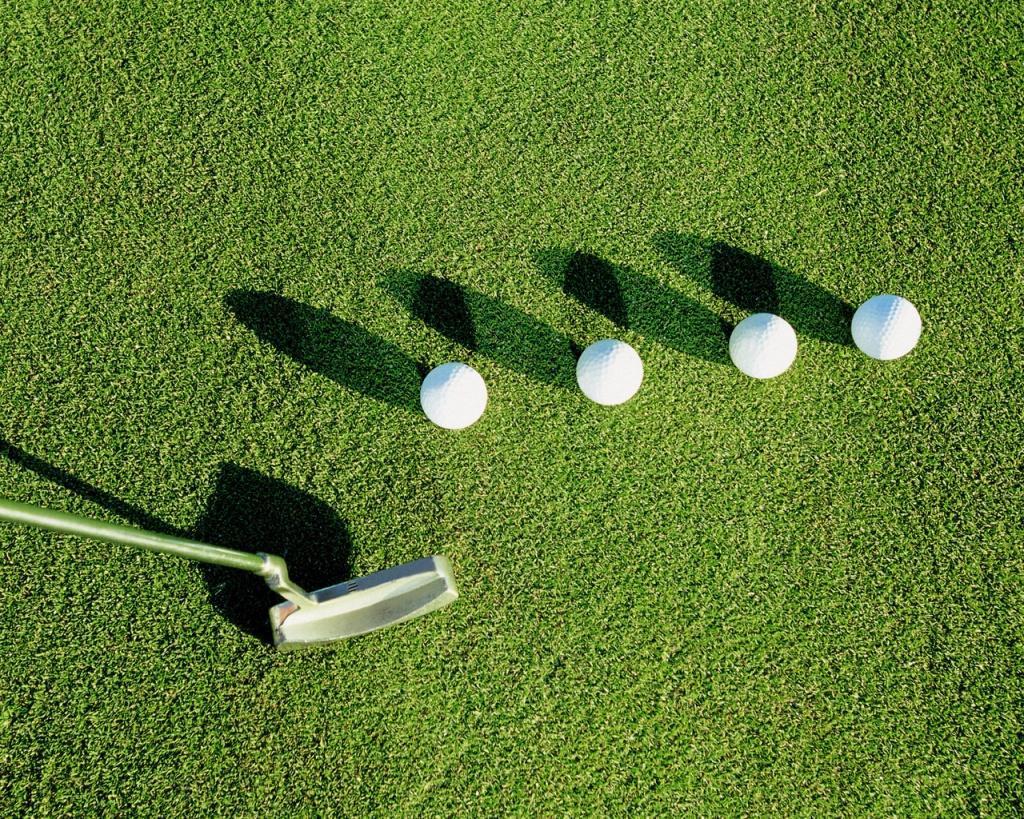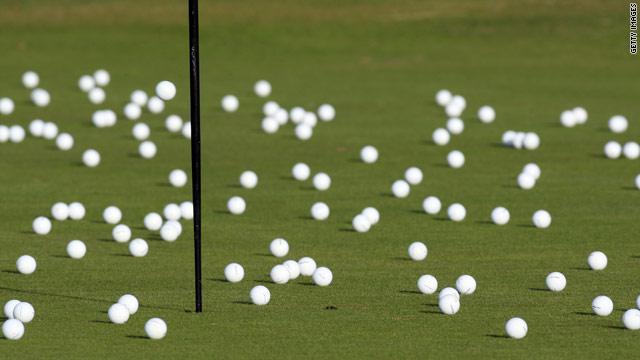The first image is the image on the left, the second image is the image on the right. Considering the images on both sides, is "Left image shows one ball next to a hole on a golf green." valid? Answer yes or no. No. The first image is the image on the left, the second image is the image on the right. Assess this claim about the two images: "Each image shows one golf ball on a green, one of them near a cup with a flag pole.". Correct or not? Answer yes or no. No. 